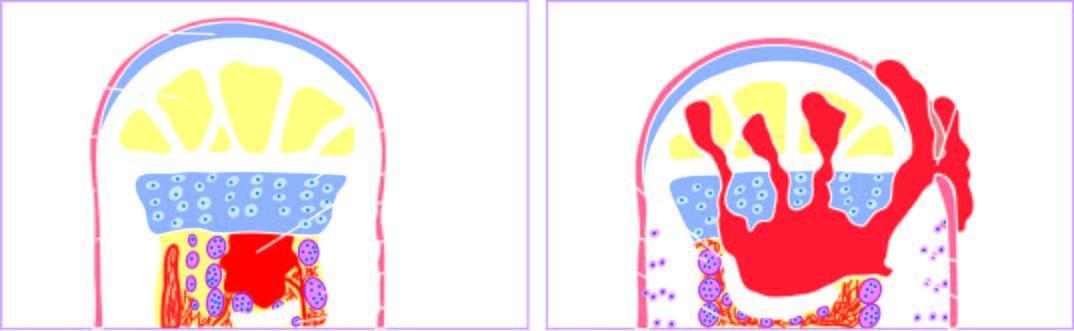does part of the endocervical mucosa produce a draining sinus?
Answer the question using a single word or phrase. No 